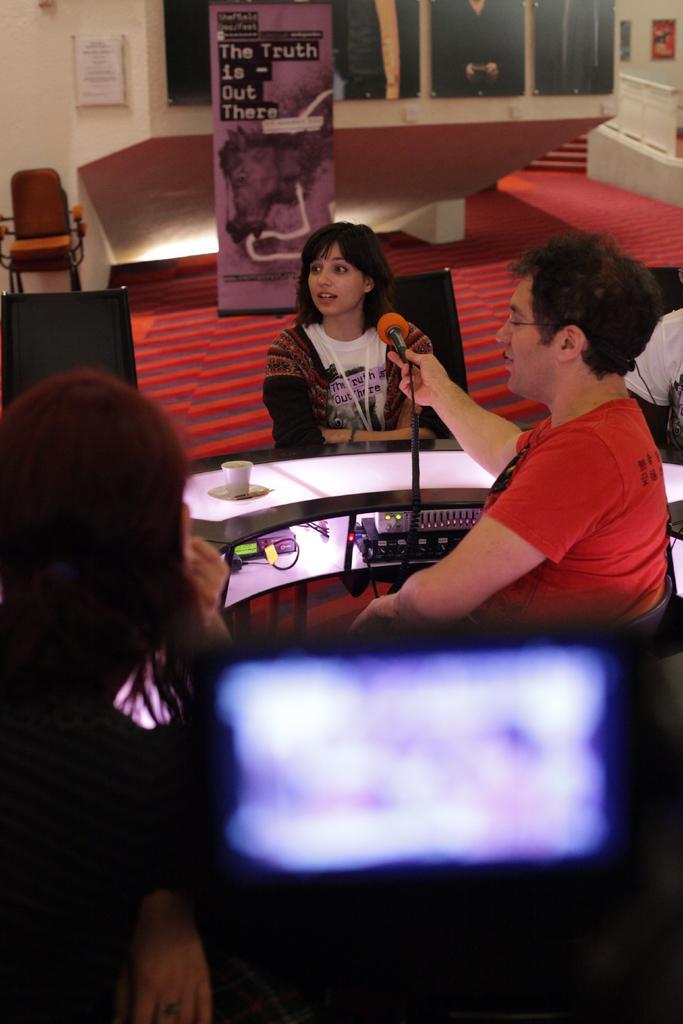How would you summarize this image in a sentence or two? On the right side of an image there is a man sitting and holding a microphone towards a woman she is sitting on the chair and here there is a light 